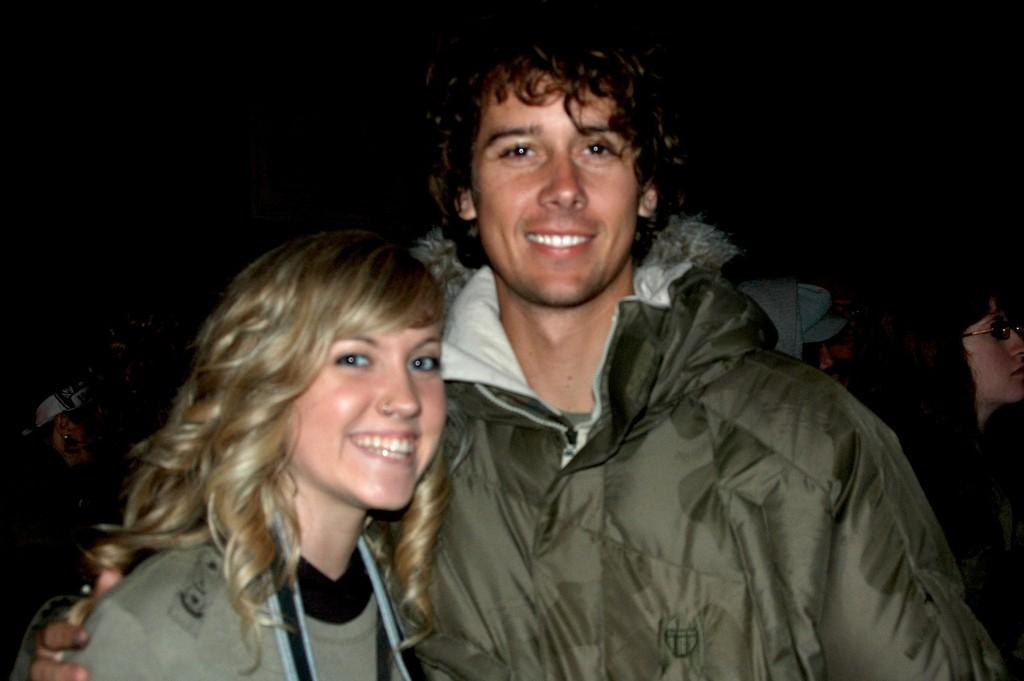Who is present in the image? There is a man and a woman in the image. What are they wearing? Both the man and woman are wearing sweaters. What are they doing in the image? They are posing for a photograph. Can you describe the background of the image? There are people in the background of the image. What is the price of the breakfast they are having in the image? There is no breakfast present in the image, so it is not possible to determine its price. 